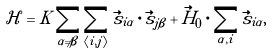Convert formula to latex. <formula><loc_0><loc_0><loc_500><loc_500>\mathcal { H } = K \sum _ { \alpha \neq \beta } \sum _ { \left \langle i , j \right \rangle } \vec { s } _ { i \alpha } \cdot \vec { s } _ { j \beta } + \vec { H } _ { 0 } \cdot \sum _ { \alpha , i } \vec { s } _ { i \alpha } ,</formula> 